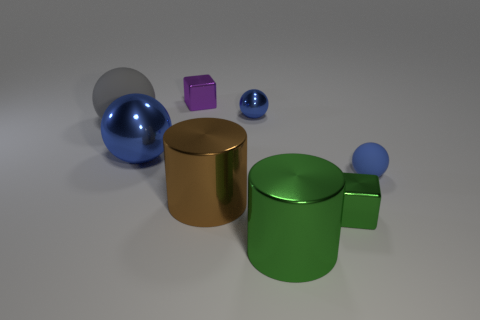Subtract all blue rubber spheres. How many spheres are left? 3 Add 2 big objects. How many objects exist? 10 Subtract all purple cubes. How many cubes are left? 1 Subtract 1 blocks. How many blocks are left? 1 Subtract all green cubes. Subtract all blue cylinders. How many cubes are left? 1 Subtract all yellow metal blocks. Subtract all gray objects. How many objects are left? 7 Add 7 small blue shiny balls. How many small blue shiny balls are left? 8 Add 8 tiny yellow metal spheres. How many tiny yellow metal spheres exist? 8 Subtract 1 green cylinders. How many objects are left? 7 Subtract all cylinders. How many objects are left? 6 